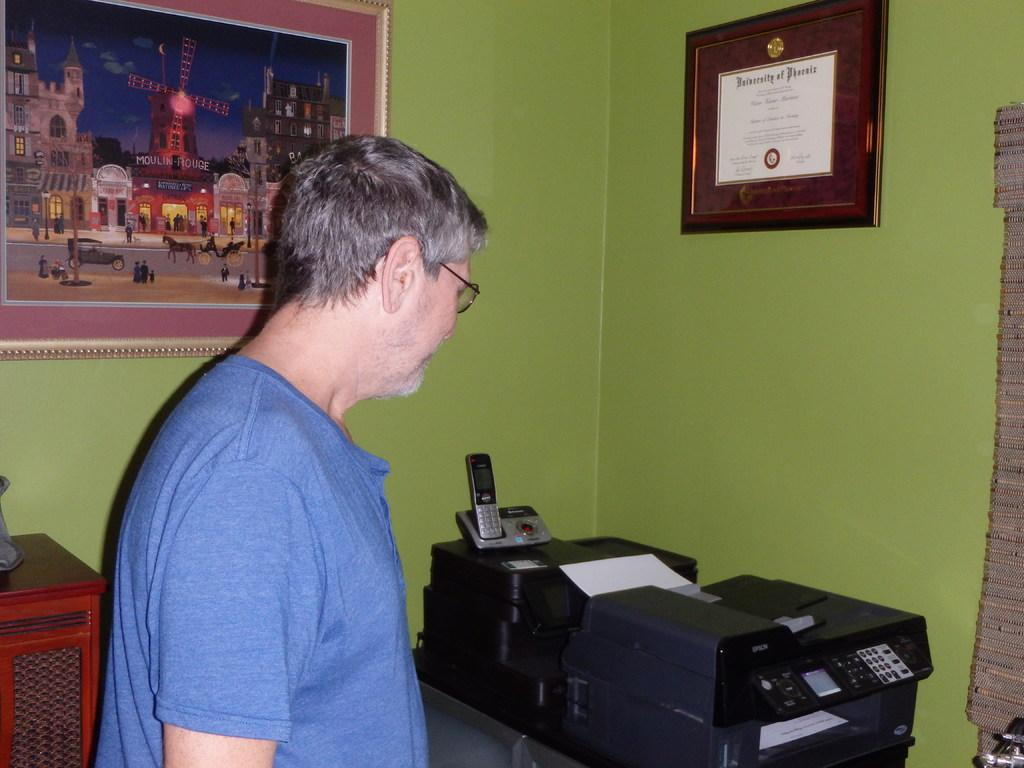<image>
Render a clear and concise summary of the photo. A man stands by a printer with a University of Phoenix diploma on the wall. 